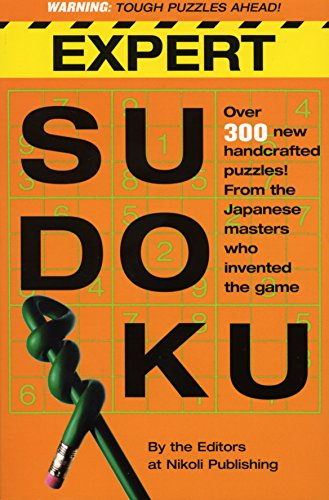Mention some notable figures or contributors specifically highlighted on this book's cover. The cover of 'Expert Sudoku' does not mention individual names of contributors; rather, it credits the 'Editors of Nikoli Publishing', the collective group behind the creation of these puzzles. 